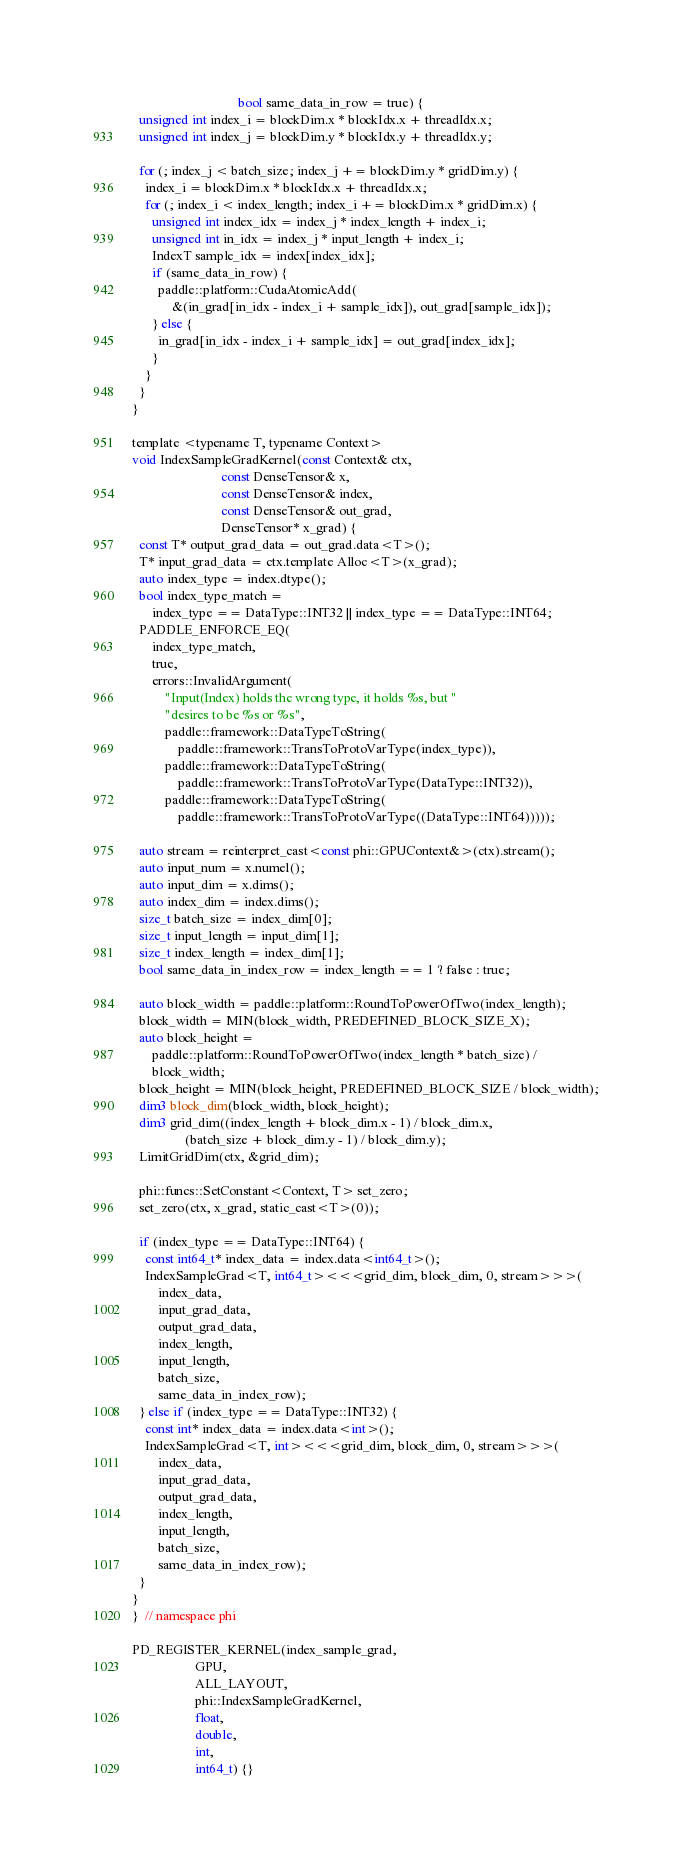<code> <loc_0><loc_0><loc_500><loc_500><_Cuda_>                                bool same_data_in_row = true) {
  unsigned int index_i = blockDim.x * blockIdx.x + threadIdx.x;
  unsigned int index_j = blockDim.y * blockIdx.y + threadIdx.y;

  for (; index_j < batch_size; index_j += blockDim.y * gridDim.y) {
    index_i = blockDim.x * blockIdx.x + threadIdx.x;
    for (; index_i < index_length; index_i += blockDim.x * gridDim.x) {
      unsigned int index_idx = index_j * index_length + index_i;
      unsigned int in_idx = index_j * input_length + index_i;
      IndexT sample_idx = index[index_idx];
      if (same_data_in_row) {
        paddle::platform::CudaAtomicAdd(
            &(in_grad[in_idx - index_i + sample_idx]), out_grad[sample_idx]);
      } else {
        in_grad[in_idx - index_i + sample_idx] = out_grad[index_idx];
      }
    }
  }
}

template <typename T, typename Context>
void IndexSampleGradKernel(const Context& ctx,
                           const DenseTensor& x,
                           const DenseTensor& index,
                           const DenseTensor& out_grad,
                           DenseTensor* x_grad) {
  const T* output_grad_data = out_grad.data<T>();
  T* input_grad_data = ctx.template Alloc<T>(x_grad);
  auto index_type = index.dtype();
  bool index_type_match =
      index_type == DataType::INT32 || index_type == DataType::INT64;
  PADDLE_ENFORCE_EQ(
      index_type_match,
      true,
      errors::InvalidArgument(
          "Input(Index) holds the wrong type, it holds %s, but "
          "desires to be %s or %s",
          paddle::framework::DataTypeToString(
              paddle::framework::TransToProtoVarType(index_type)),
          paddle::framework::DataTypeToString(
              paddle::framework::TransToProtoVarType(DataType::INT32)),
          paddle::framework::DataTypeToString(
              paddle::framework::TransToProtoVarType((DataType::INT64)))));

  auto stream = reinterpret_cast<const phi::GPUContext&>(ctx).stream();
  auto input_num = x.numel();
  auto input_dim = x.dims();
  auto index_dim = index.dims();
  size_t batch_size = index_dim[0];
  size_t input_length = input_dim[1];
  size_t index_length = index_dim[1];
  bool same_data_in_index_row = index_length == 1 ? false : true;

  auto block_width = paddle::platform::RoundToPowerOfTwo(index_length);
  block_width = MIN(block_width, PREDEFINED_BLOCK_SIZE_X);
  auto block_height =
      paddle::platform::RoundToPowerOfTwo(index_length * batch_size) /
      block_width;
  block_height = MIN(block_height, PREDEFINED_BLOCK_SIZE / block_width);
  dim3 block_dim(block_width, block_height);
  dim3 grid_dim((index_length + block_dim.x - 1) / block_dim.x,
                (batch_size + block_dim.y - 1) / block_dim.y);
  LimitGridDim(ctx, &grid_dim);

  phi::funcs::SetConstant<Context, T> set_zero;
  set_zero(ctx, x_grad, static_cast<T>(0));

  if (index_type == DataType::INT64) {
    const int64_t* index_data = index.data<int64_t>();
    IndexSampleGrad<T, int64_t><<<grid_dim, block_dim, 0, stream>>>(
        index_data,
        input_grad_data,
        output_grad_data,
        index_length,
        input_length,
        batch_size,
        same_data_in_index_row);
  } else if (index_type == DataType::INT32) {
    const int* index_data = index.data<int>();
    IndexSampleGrad<T, int><<<grid_dim, block_dim, 0, stream>>>(
        index_data,
        input_grad_data,
        output_grad_data,
        index_length,
        input_length,
        batch_size,
        same_data_in_index_row);
  }
}
}  // namespace phi

PD_REGISTER_KERNEL(index_sample_grad,
                   GPU,
                   ALL_LAYOUT,
                   phi::IndexSampleGradKernel,
                   float,
                   double,
                   int,
                   int64_t) {}
</code> 